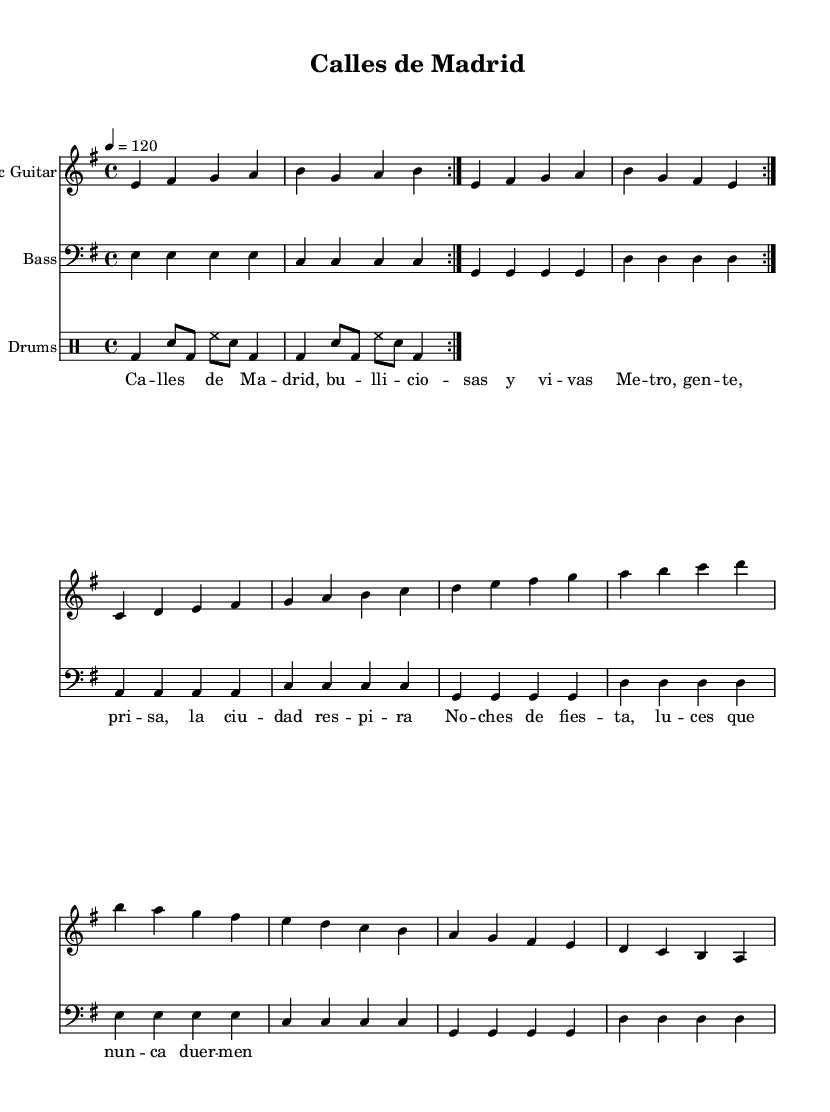What is the key signature of this music? The key signature is E minor, identified by one sharp (F#) in the key signature at the beginning of the staff.
Answer: E minor What is the time signature of the music? The time signature is 4/4, shown at the beginning of the piece, indicating four beats per measure.
Answer: 4/4 What is the tempo marking of the piece? The tempo marking is 120 beats per minute, indicated by the number "120" next to the tempo notation in the music sheet.
Answer: 120 How many measures are repeated in the guitar part? The guitar part repeats two measures, indicated by the "volta" marking which shows the section that needs to be repeated.
Answer: 2 What is the drum pattern for the first measure? The first measure of the drum part includes a bass drum, snare, and hi-hat played in a specific rhythm, which can be counted to identify the beats and their arrangement.
Answer: Bass drum, snare, hi-hat What themes are reflected in the lyrics of the song? The lyrics reference urban life in Madrid, mentioning bustling streets, nightlife, and the essence of the city, which is conveyed through the words describing the atmosphere and experiences of city dwellers.
Answer: Urban life What instruments are featured in this sheet music? The instruments featured in the sheet music are Electric Guitar, Bass, and Drums, as indicated by their respective staff headings at the beginning of each part.
Answer: Electric Guitar, Bass, Drums 